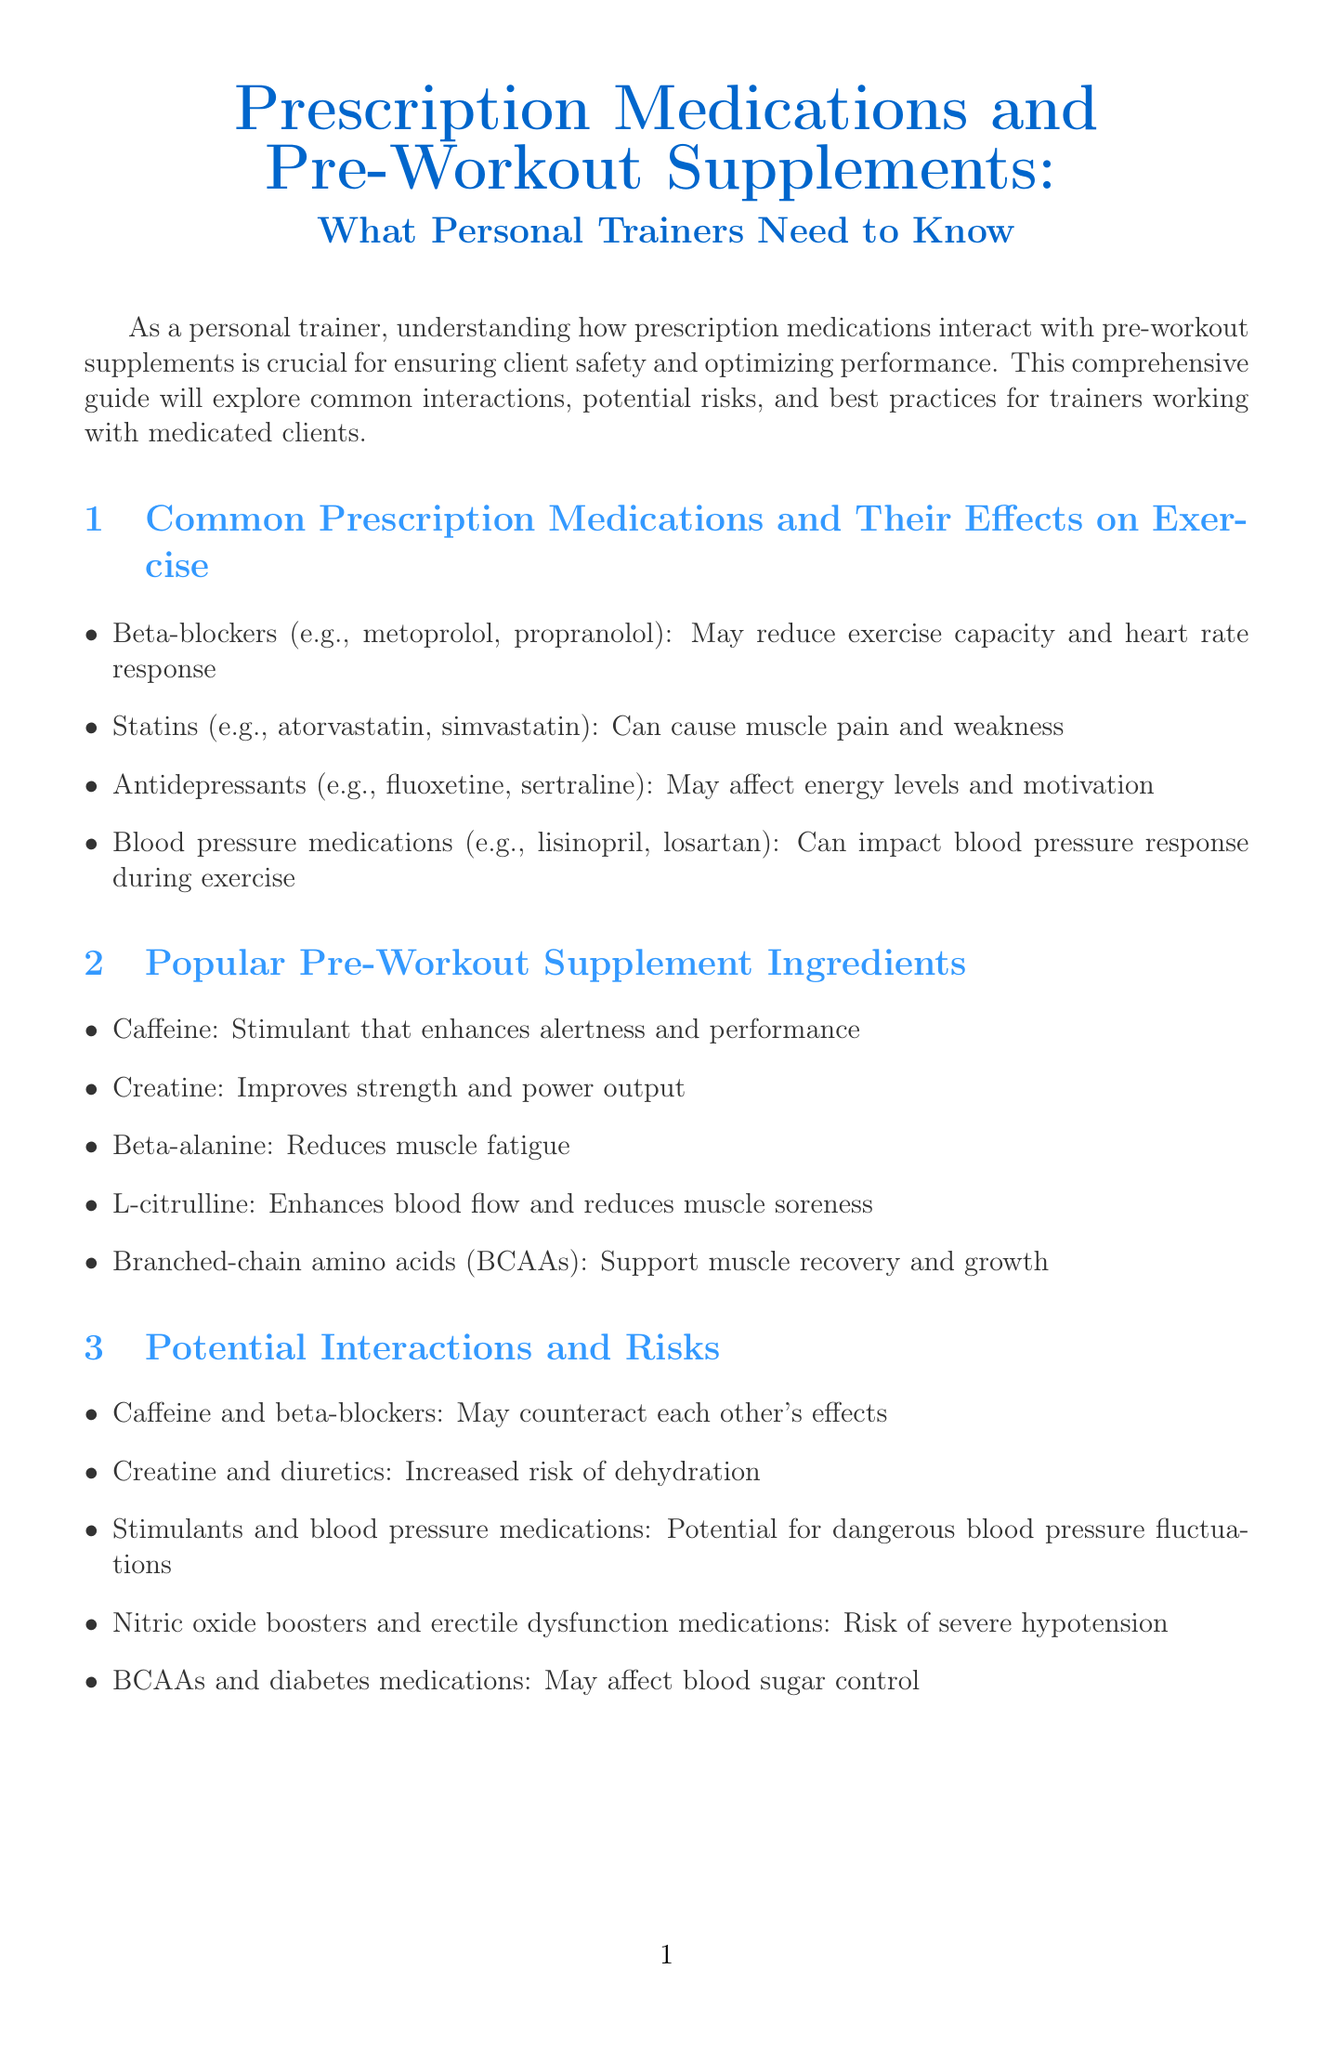what is the title of the newsletter? The title of the newsletter is explicitly stated at the top of the document.
Answer: Prescription Medications and Pre-Workout Supplements: What Personal Trainers Need to Know name two common prescription medications mentioned in the document. The document lists specific examples of common prescription medications in the first section.
Answer: Beta-blockers, Statins which ingredient is known to improve strength and power output? The document specifies which pre-workout supplement ingredient has that effect in the second section.
Answer: Creatine what is one potential risk of combining caffeine with beta-blockers? The document highlights specific interactions between medications and supplements, mentioning this risk explicitly.
Answer: May counteract each other's effects what should personal trainers do before their clients use pre-workout supplements? The best practices section advises trainers on actions regarding client safety and supplement use.
Answer: Encourage clients to consult their healthcare provider who is the case study client in the newsletter? The case study introduces a specific character to illustrate medication management for trainers.
Answer: John what are BCAAs used for according to the newsletter? The document states the purpose of branched-chain amino acids in the section on supplement ingredients.
Answer: Support muscle recovery and growth which organization offers certification programs as a resource? The resources section lists educational institutions for personal trainers, including this organization.
Answer: National Strength and Conditioning Association (NSCA) 